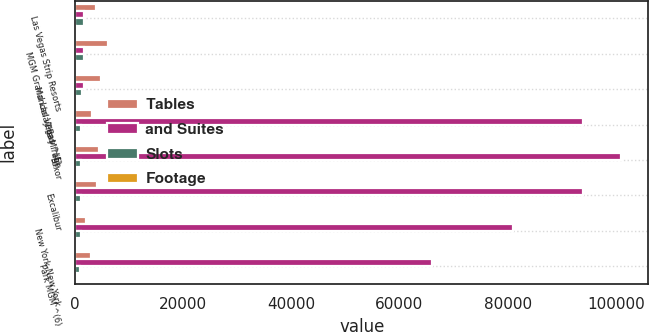Convert chart to OTSL. <chart><loc_0><loc_0><loc_500><loc_500><stacked_bar_chart><ecel><fcel>Las Vegas Strip Resorts<fcel>MGM Grand Las Vegas ^(4)<fcel>Mandalay Bay ^(5)<fcel>The Mirage<fcel>Luxor<fcel>Excalibur<fcel>New York-New York<fcel>Park MGM ^(6)<nl><fcel>Tables<fcel>3933<fcel>6131<fcel>4750<fcel>3044<fcel>4397<fcel>3981<fcel>2024<fcel>2898<nl><fcel>and Suites<fcel>1570<fcel>1570<fcel>1570<fcel>94000<fcel>101000<fcel>94000<fcel>81000<fcel>66000<nl><fcel>Slots<fcel>1707<fcel>1570<fcel>1213<fcel>1189<fcel>1026<fcel>1153<fcel>1148<fcel>842<nl><fcel>Footage<fcel>147<fcel>127<fcel>71<fcel>82<fcel>54<fcel>51<fcel>66<fcel>56<nl></chart> 